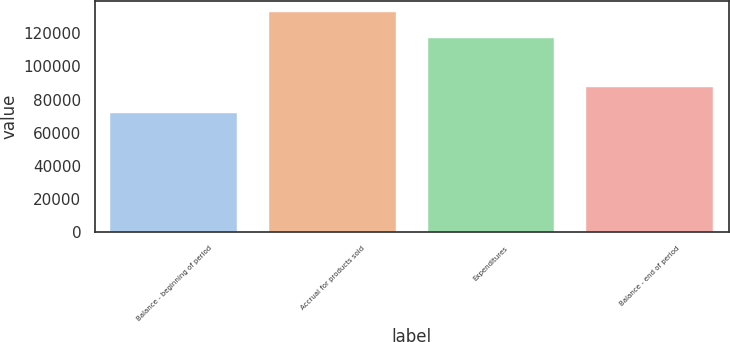Convert chart. <chart><loc_0><loc_0><loc_500><loc_500><bar_chart><fcel>Balance - beginning of period<fcel>Accrual for products sold<fcel>Expenditures<fcel>Balance - end of period<nl><fcel>71636<fcel>132644<fcel>116872<fcel>87408<nl></chart> 